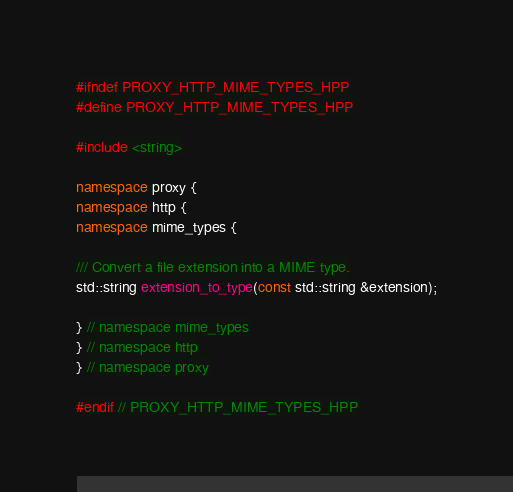<code> <loc_0><loc_0><loc_500><loc_500><_C++_>#ifndef PROXY_HTTP_MIME_TYPES_HPP
#define PROXY_HTTP_MIME_TYPES_HPP

#include <string>

namespace proxy {
namespace http {
namespace mime_types {

/// Convert a file extension into a MIME type.
std::string extension_to_type(const std::string &extension);

} // namespace mime_types
} // namespace http
} // namespace proxy

#endif // PROXY_HTTP_MIME_TYPES_HPP
</code> 